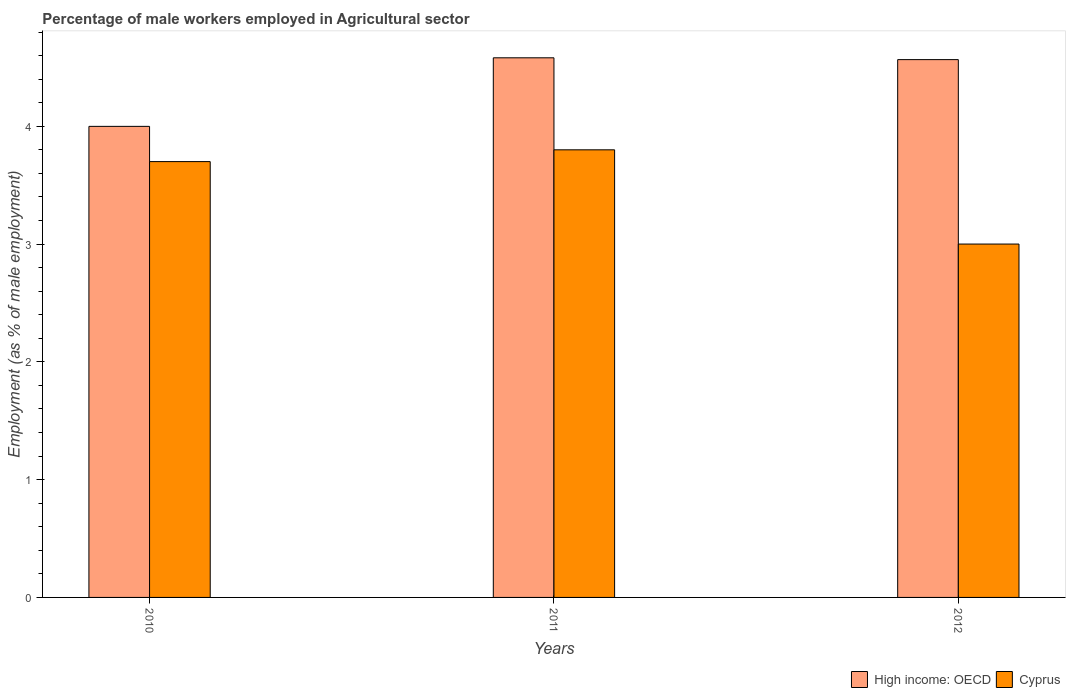How many different coloured bars are there?
Provide a short and direct response. 2. Are the number of bars per tick equal to the number of legend labels?
Ensure brevity in your answer.  Yes. Are the number of bars on each tick of the X-axis equal?
Offer a terse response. Yes. What is the percentage of male workers employed in Agricultural sector in High income: OECD in 2010?
Your response must be concise. 4. Across all years, what is the maximum percentage of male workers employed in Agricultural sector in Cyprus?
Offer a very short reply. 3.8. What is the total percentage of male workers employed in Agricultural sector in High income: OECD in the graph?
Provide a short and direct response. 13.15. What is the difference between the percentage of male workers employed in Agricultural sector in Cyprus in 2010 and that in 2011?
Offer a terse response. -0.1. What is the difference between the percentage of male workers employed in Agricultural sector in Cyprus in 2010 and the percentage of male workers employed in Agricultural sector in High income: OECD in 2012?
Your answer should be very brief. -0.87. In the year 2012, what is the difference between the percentage of male workers employed in Agricultural sector in Cyprus and percentage of male workers employed in Agricultural sector in High income: OECD?
Your answer should be very brief. -1.57. What is the ratio of the percentage of male workers employed in Agricultural sector in Cyprus in 2010 to that in 2011?
Provide a succinct answer. 0.97. Is the difference between the percentage of male workers employed in Agricultural sector in Cyprus in 2010 and 2012 greater than the difference between the percentage of male workers employed in Agricultural sector in High income: OECD in 2010 and 2012?
Make the answer very short. Yes. What is the difference between the highest and the second highest percentage of male workers employed in Agricultural sector in High income: OECD?
Your response must be concise. 0.02. What is the difference between the highest and the lowest percentage of male workers employed in Agricultural sector in High income: OECD?
Offer a very short reply. 0.58. In how many years, is the percentage of male workers employed in Agricultural sector in High income: OECD greater than the average percentage of male workers employed in Agricultural sector in High income: OECD taken over all years?
Provide a succinct answer. 2. What does the 2nd bar from the left in 2012 represents?
Keep it short and to the point. Cyprus. What does the 2nd bar from the right in 2011 represents?
Make the answer very short. High income: OECD. How many bars are there?
Your answer should be very brief. 6. Are all the bars in the graph horizontal?
Offer a terse response. No. How many years are there in the graph?
Provide a succinct answer. 3. What is the difference between two consecutive major ticks on the Y-axis?
Make the answer very short. 1. Where does the legend appear in the graph?
Provide a short and direct response. Bottom right. How many legend labels are there?
Make the answer very short. 2. How are the legend labels stacked?
Offer a very short reply. Horizontal. What is the title of the graph?
Provide a succinct answer. Percentage of male workers employed in Agricultural sector. Does "Kuwait" appear as one of the legend labels in the graph?
Keep it short and to the point. No. What is the label or title of the X-axis?
Give a very brief answer. Years. What is the label or title of the Y-axis?
Give a very brief answer. Employment (as % of male employment). What is the Employment (as % of male employment) in High income: OECD in 2010?
Your response must be concise. 4. What is the Employment (as % of male employment) of Cyprus in 2010?
Your answer should be very brief. 3.7. What is the Employment (as % of male employment) in High income: OECD in 2011?
Your answer should be very brief. 4.58. What is the Employment (as % of male employment) in Cyprus in 2011?
Keep it short and to the point. 3.8. What is the Employment (as % of male employment) of High income: OECD in 2012?
Offer a very short reply. 4.57. Across all years, what is the maximum Employment (as % of male employment) in High income: OECD?
Provide a succinct answer. 4.58. Across all years, what is the maximum Employment (as % of male employment) of Cyprus?
Offer a terse response. 3.8. Across all years, what is the minimum Employment (as % of male employment) in High income: OECD?
Ensure brevity in your answer.  4. Across all years, what is the minimum Employment (as % of male employment) of Cyprus?
Make the answer very short. 3. What is the total Employment (as % of male employment) in High income: OECD in the graph?
Your response must be concise. 13.15. What is the total Employment (as % of male employment) in Cyprus in the graph?
Ensure brevity in your answer.  10.5. What is the difference between the Employment (as % of male employment) in High income: OECD in 2010 and that in 2011?
Your answer should be compact. -0.58. What is the difference between the Employment (as % of male employment) in High income: OECD in 2010 and that in 2012?
Offer a terse response. -0.57. What is the difference between the Employment (as % of male employment) of Cyprus in 2010 and that in 2012?
Your answer should be very brief. 0.7. What is the difference between the Employment (as % of male employment) in High income: OECD in 2011 and that in 2012?
Keep it short and to the point. 0.02. What is the difference between the Employment (as % of male employment) of Cyprus in 2011 and that in 2012?
Give a very brief answer. 0.8. What is the difference between the Employment (as % of male employment) in High income: OECD in 2010 and the Employment (as % of male employment) in Cyprus in 2011?
Offer a terse response. 0.2. What is the difference between the Employment (as % of male employment) in High income: OECD in 2010 and the Employment (as % of male employment) in Cyprus in 2012?
Keep it short and to the point. 1. What is the difference between the Employment (as % of male employment) of High income: OECD in 2011 and the Employment (as % of male employment) of Cyprus in 2012?
Your answer should be very brief. 1.58. What is the average Employment (as % of male employment) in High income: OECD per year?
Give a very brief answer. 4.38. In the year 2010, what is the difference between the Employment (as % of male employment) of High income: OECD and Employment (as % of male employment) of Cyprus?
Your answer should be compact. 0.3. In the year 2011, what is the difference between the Employment (as % of male employment) of High income: OECD and Employment (as % of male employment) of Cyprus?
Provide a short and direct response. 0.78. In the year 2012, what is the difference between the Employment (as % of male employment) of High income: OECD and Employment (as % of male employment) of Cyprus?
Offer a very short reply. 1.57. What is the ratio of the Employment (as % of male employment) in High income: OECD in 2010 to that in 2011?
Offer a very short reply. 0.87. What is the ratio of the Employment (as % of male employment) in Cyprus in 2010 to that in 2011?
Provide a succinct answer. 0.97. What is the ratio of the Employment (as % of male employment) in High income: OECD in 2010 to that in 2012?
Your answer should be compact. 0.88. What is the ratio of the Employment (as % of male employment) in Cyprus in 2010 to that in 2012?
Your answer should be compact. 1.23. What is the ratio of the Employment (as % of male employment) in Cyprus in 2011 to that in 2012?
Offer a very short reply. 1.27. What is the difference between the highest and the second highest Employment (as % of male employment) of High income: OECD?
Offer a terse response. 0.02. What is the difference between the highest and the second highest Employment (as % of male employment) of Cyprus?
Your answer should be compact. 0.1. What is the difference between the highest and the lowest Employment (as % of male employment) of High income: OECD?
Your answer should be very brief. 0.58. What is the difference between the highest and the lowest Employment (as % of male employment) of Cyprus?
Your answer should be compact. 0.8. 